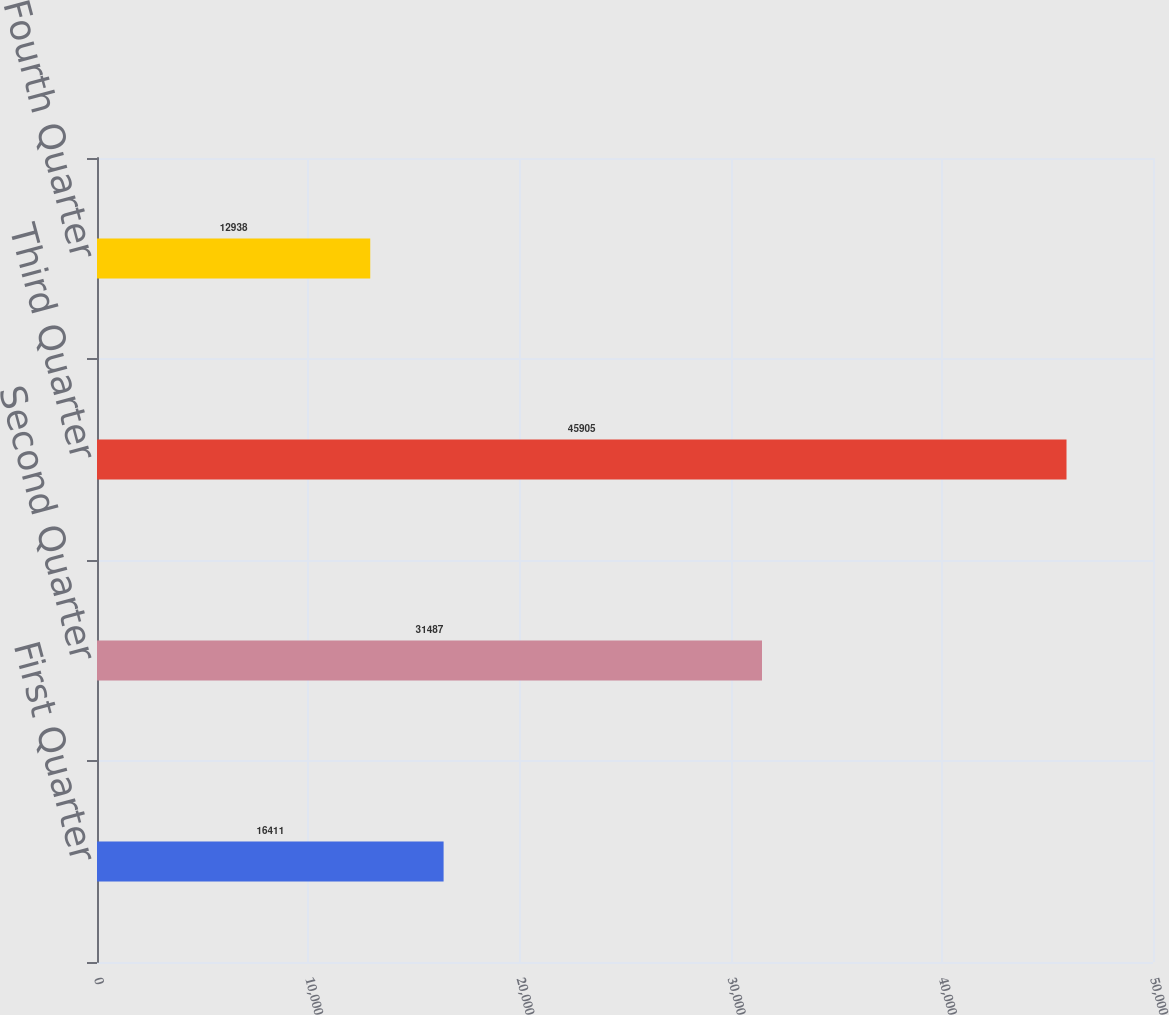Convert chart to OTSL. <chart><loc_0><loc_0><loc_500><loc_500><bar_chart><fcel>First Quarter<fcel>Second Quarter<fcel>Third Quarter<fcel>Fourth Quarter<nl><fcel>16411<fcel>31487<fcel>45905<fcel>12938<nl></chart> 